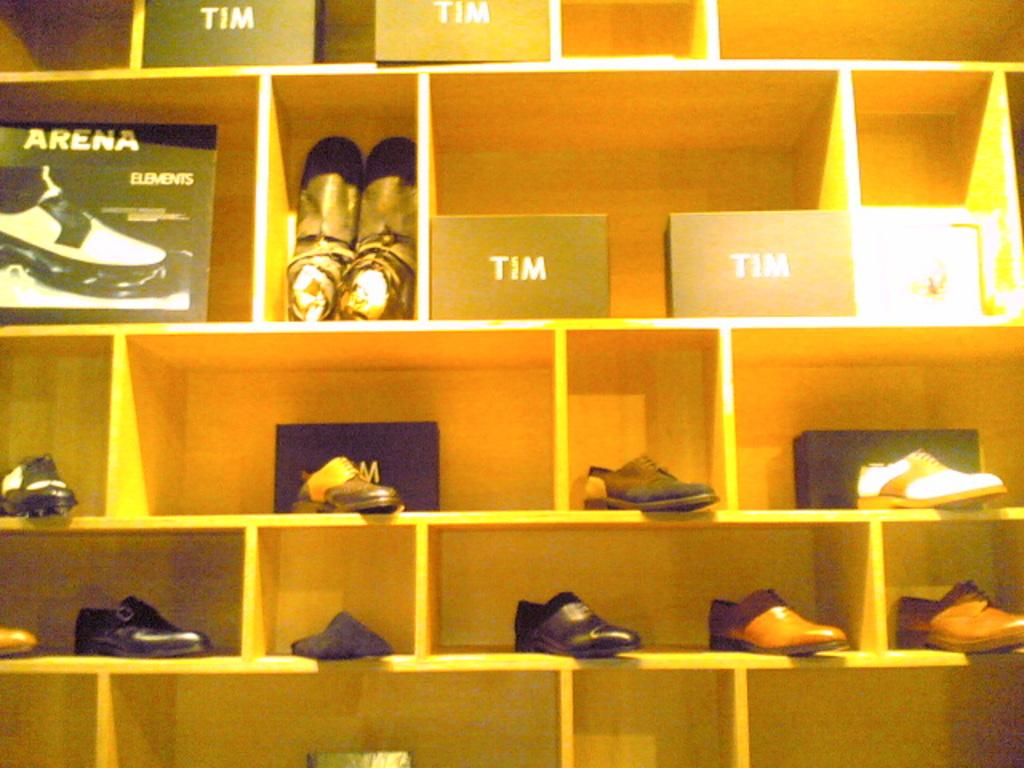What objects are present in the image? There are shoes and boxes in the image. Where are the boxes located? The boxes are on shelves in the image. What can be found on the boxes? There is writing on the boxes. What type of authority is depicted on the wall in the image? There is no wall or authority figure present in the image. 